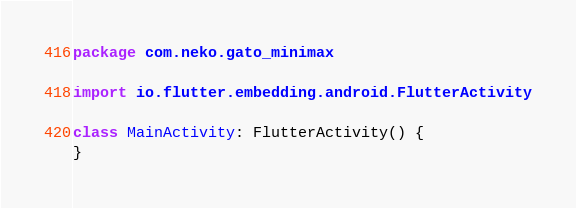Convert code to text. <code><loc_0><loc_0><loc_500><loc_500><_Kotlin_>package com.neko.gato_minimax

import io.flutter.embedding.android.FlutterActivity

class MainActivity: FlutterActivity() {
}
</code> 